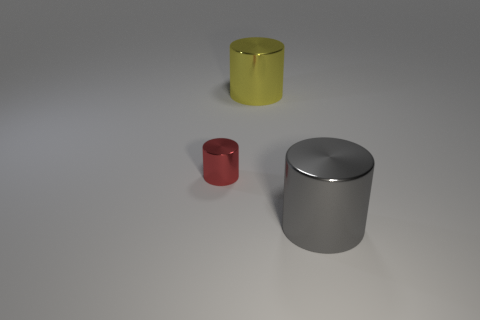Subtract all gray metal cylinders. How many cylinders are left? 2 Add 1 green matte spheres. How many objects exist? 4 Subtract all yellow cylinders. How many cylinders are left? 2 Subtract 0 red balls. How many objects are left? 3 Subtract all yellow cylinders. Subtract all purple cubes. How many cylinders are left? 2 Subtract all cyan matte cylinders. Subtract all yellow shiny things. How many objects are left? 2 Add 1 metallic objects. How many metallic objects are left? 4 Add 3 large red rubber cylinders. How many large red rubber cylinders exist? 3 